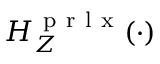Convert formula to latex. <formula><loc_0><loc_0><loc_500><loc_500>H _ { Z } ^ { p r l x } ( \cdot )</formula> 